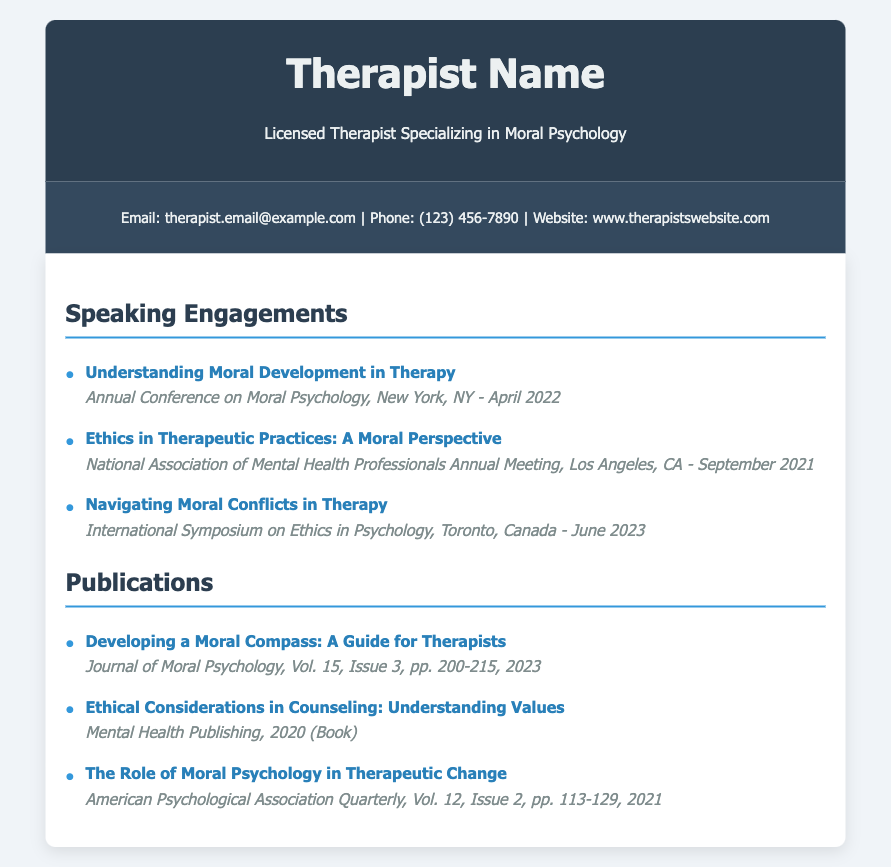What is the name of the therapist? The name of the therapist is prominently mentioned in the header section of the document.
Answer: Therapist Name In which city did the speaking engagement on "Ethics in Therapeutic Practices: A Moral Perspective" occur? The city for this speaking engagement is noted in the details of the engagement.
Answer: Los Angeles, CA What is the publication year of "Developing a Moral Compass: A Guide for Therapists"? The year for this publication is listed alongside the title in the publications section of the document.
Answer: 2023 How many speaking engagements are listed in the document? The count of speaking engagements can be obtained by simply counting the listed items in the relevant section.
Answer: 3 Which professional event was held in June 2023? The event in June 2023 is mentioned in the speaking engagements section.
Answer: International Symposium on Ethics in Psychology What is the title of the publication that discusses ethical considerations in counseling? The title can be found specifically in the publications section and denotes focus on ethical considerations.
Answer: Ethical Considerations in Counseling: Understanding Values What volume and issue number is associated with "The Role of Moral Psychology in Therapeutic Change"? This information is detailed alongside the publication title in the document.
Answer: Vol. 12, Issue 2 How many publications are listed in the document? Counting the items in the publications section will yield this number.
Answer: 3 What is the focus of the presentation "Navigating Moral Conflicts in Therapy"? The title suggests the focus area of this speaking engagement as noted in the engagements section.
Answer: Moral Conflicts in Therapy 